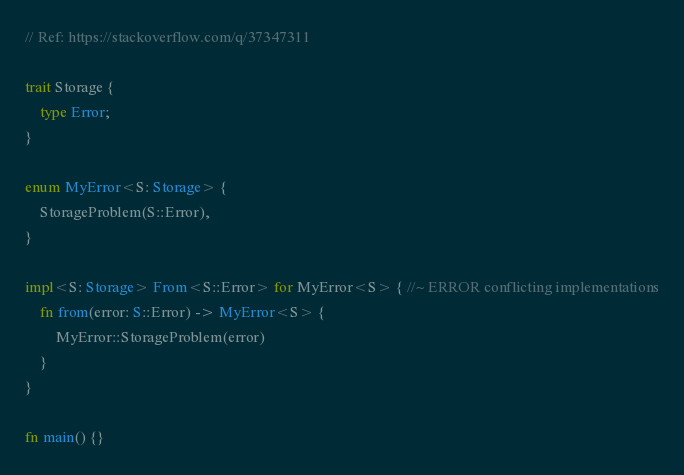Convert code to text. <code><loc_0><loc_0><loc_500><loc_500><_Rust_>// Ref: https://stackoverflow.com/q/37347311

trait Storage {
    type Error;
}

enum MyError<S: Storage> {
    StorageProblem(S::Error),
}

impl<S: Storage> From<S::Error> for MyError<S> { //~ ERROR conflicting implementations
    fn from(error: S::Error) -> MyError<S> {
        MyError::StorageProblem(error)
    }
}

fn main() {}
</code> 